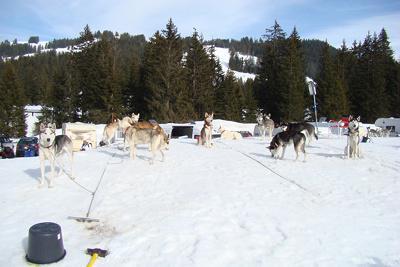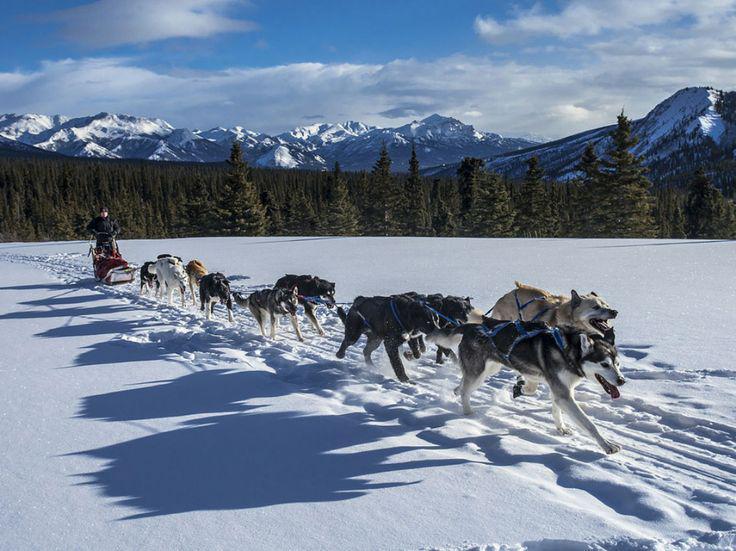The first image is the image on the left, the second image is the image on the right. For the images shown, is this caption "Only one of the images shows a team of dogs pulling a sled." true? Answer yes or no. Yes. The first image is the image on the left, the second image is the image on the right. For the images shown, is this caption "One image shows a sled dog team moving down a path in the snow, and the other image shows sled dogs that are not hitched or working." true? Answer yes or no. Yes. 